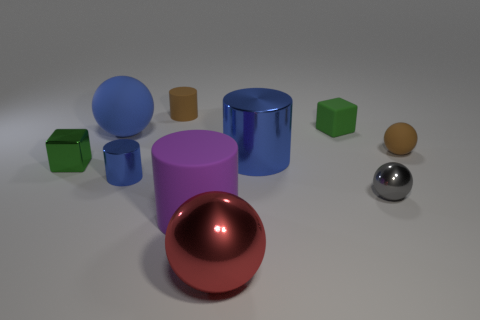What is the shape of the gray thing?
Give a very brief answer. Sphere. What is the size of the rubber thing that is on the left side of the purple object and in front of the brown rubber cylinder?
Make the answer very short. Large. There is a blue thing right of the red shiny object; what is it made of?
Your answer should be compact. Metal. There is a matte cube; does it have the same color as the large ball in front of the tiny shiny cube?
Make the answer very short. No. How many things are big cylinders that are behind the gray sphere or rubber objects to the right of the large shiny sphere?
Make the answer very short. 3. There is a metal thing that is both behind the small blue shiny cylinder and on the right side of the big red metallic sphere; what color is it?
Your answer should be very brief. Blue. Are there more big red things than big red blocks?
Your answer should be very brief. Yes. Does the tiny brown matte object that is to the left of the big blue shiny thing have the same shape as the large blue matte object?
Provide a succinct answer. No. How many rubber objects are brown things or tiny yellow objects?
Your response must be concise. 2. Are there any small blue cylinders made of the same material as the large blue ball?
Offer a very short reply. No. 